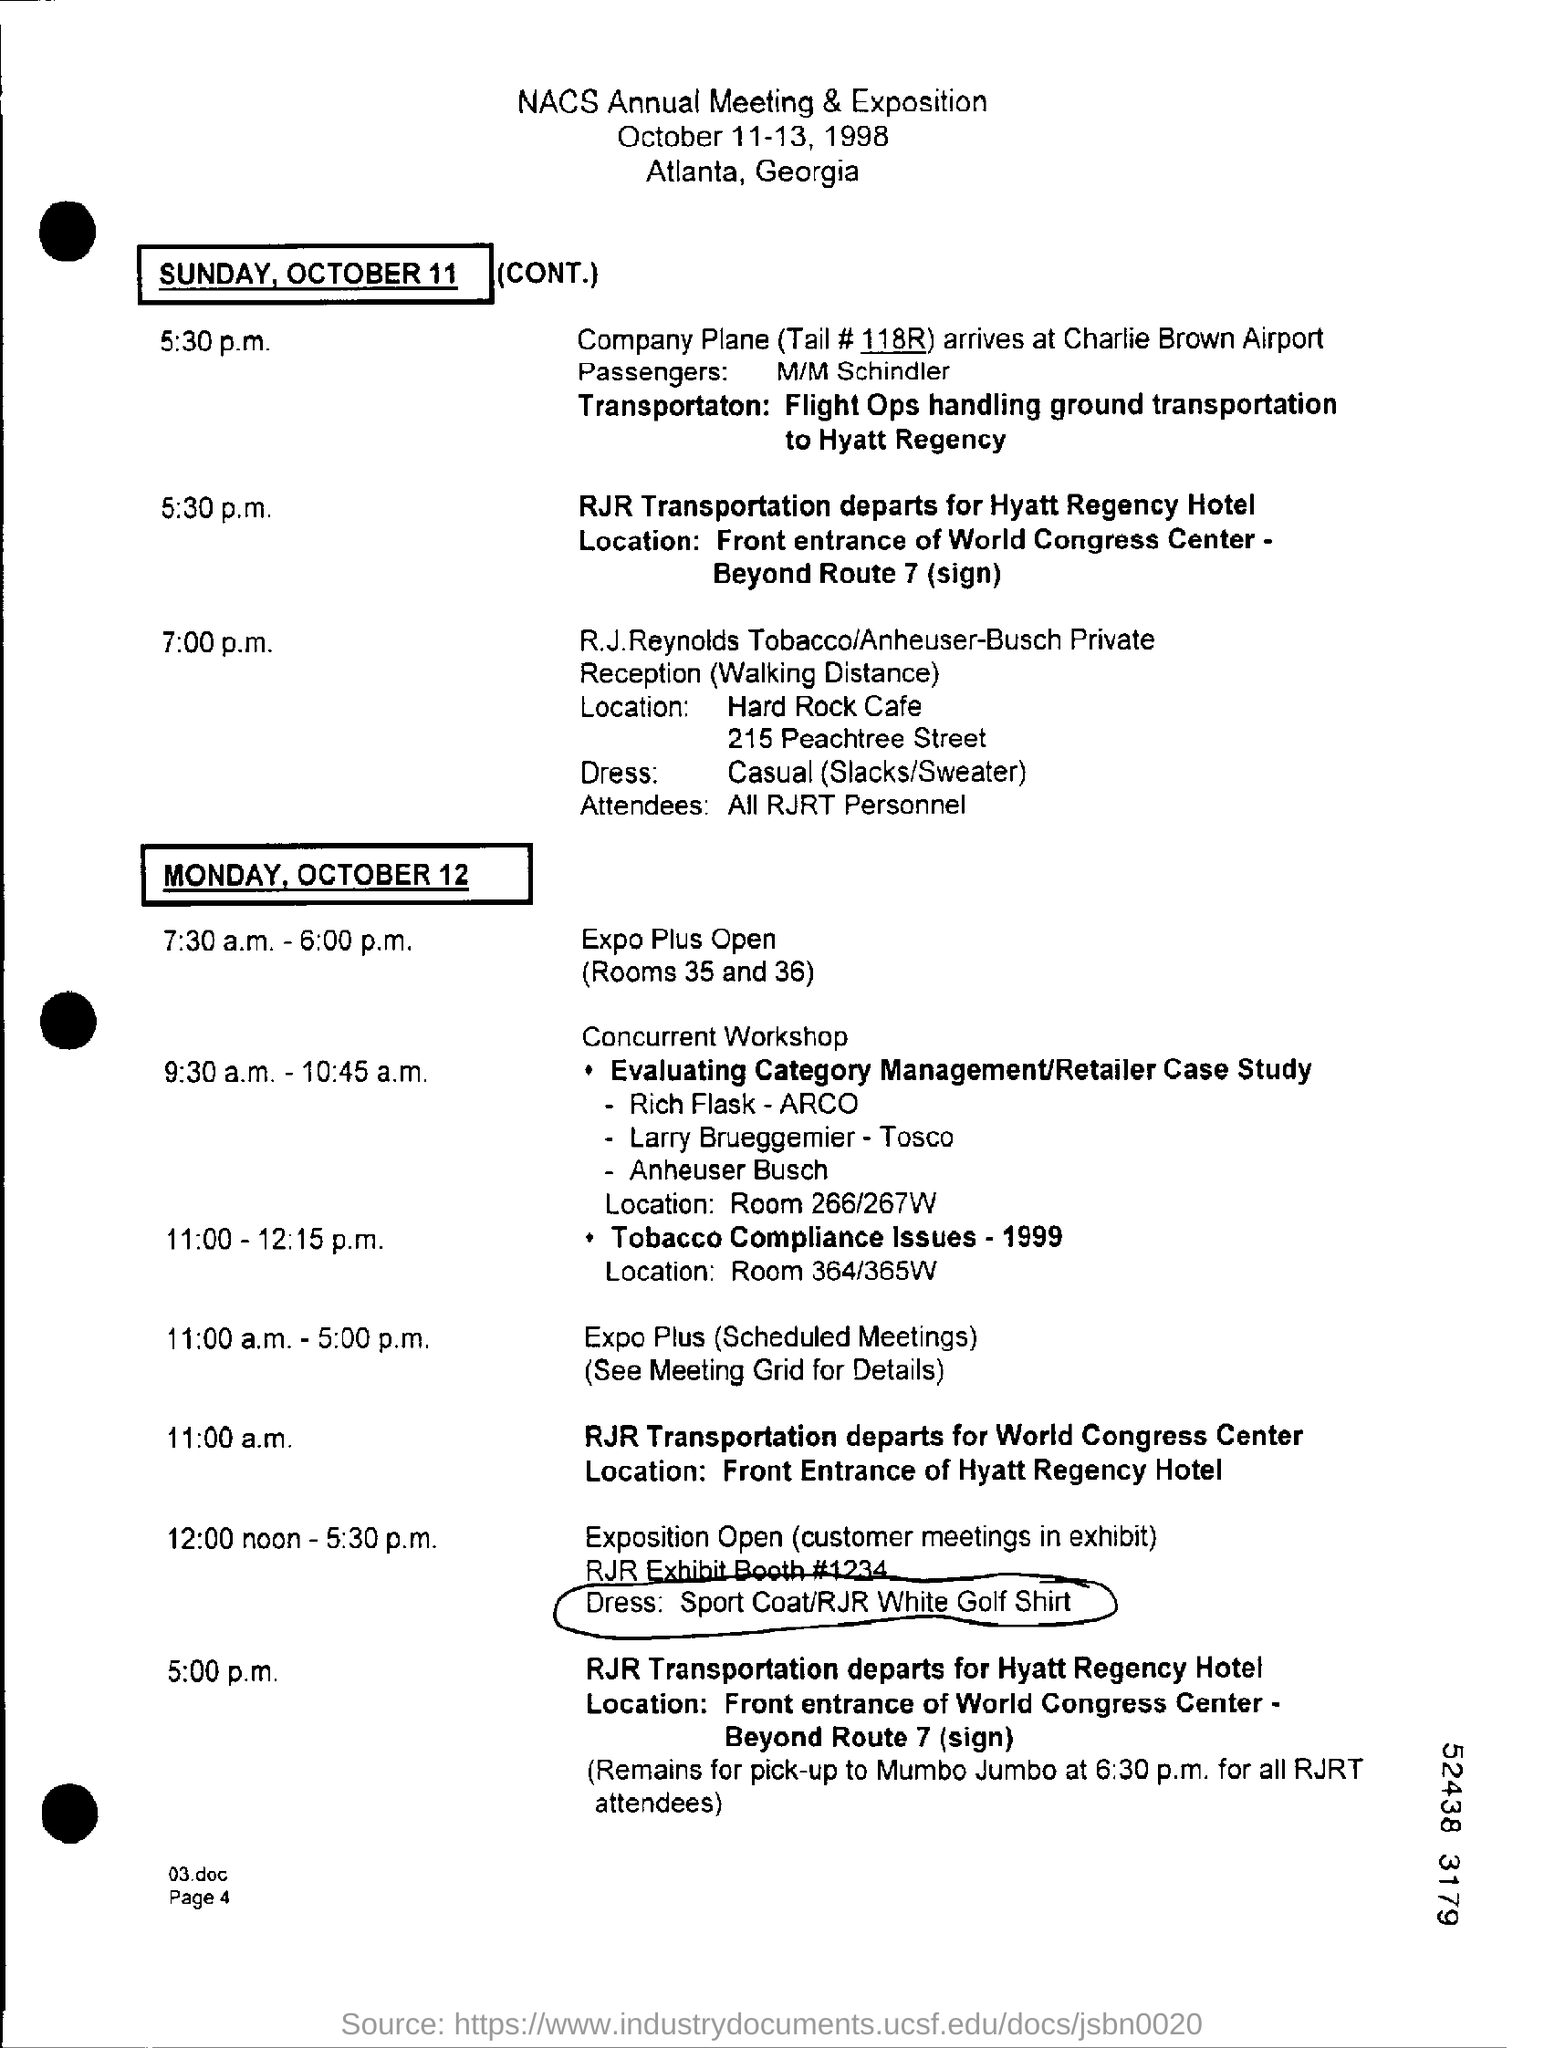Point out several critical features in this image. The tail number for the aircraft is 118R... The National Association of Convenience Stores' annual meeting and exposition is taking place in Atlanta, Georgia. The National Association of Convenience Stores annual meeting and exposition will take place on October 11-13, 1998. 